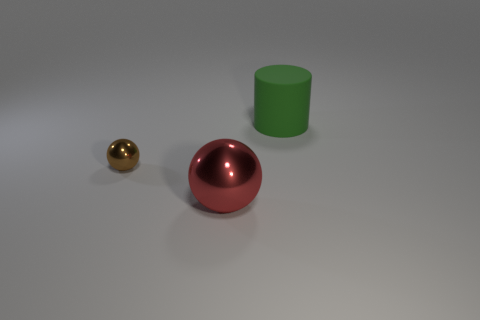Is there any other thing that is the same material as the big green cylinder?
Offer a terse response. No. Is there any other thing that has the same size as the brown metal thing?
Offer a terse response. No. Is there anything else that is the same shape as the large green matte thing?
Keep it short and to the point. No. What color is the tiny ball that is the same material as the big sphere?
Your answer should be very brief. Brown. Is there a large rubber cylinder right of the shiny thing that is to the left of the ball that is in front of the small brown thing?
Your answer should be very brief. Yes. Is the number of large metal balls that are on the right side of the large green cylinder less than the number of big red things that are in front of the brown shiny sphere?
Your answer should be compact. Yes. How many tiny brown things are the same material as the big red ball?
Make the answer very short. 1. There is a red metal ball; is it the same size as the rubber cylinder that is to the right of the large metallic ball?
Keep it short and to the point. Yes. What size is the object on the right side of the metallic ball that is in front of the metal ball that is to the left of the big shiny object?
Give a very brief answer. Large. Are there more brown balls to the left of the big red metal sphere than matte cylinders to the left of the green matte thing?
Your answer should be very brief. Yes. 